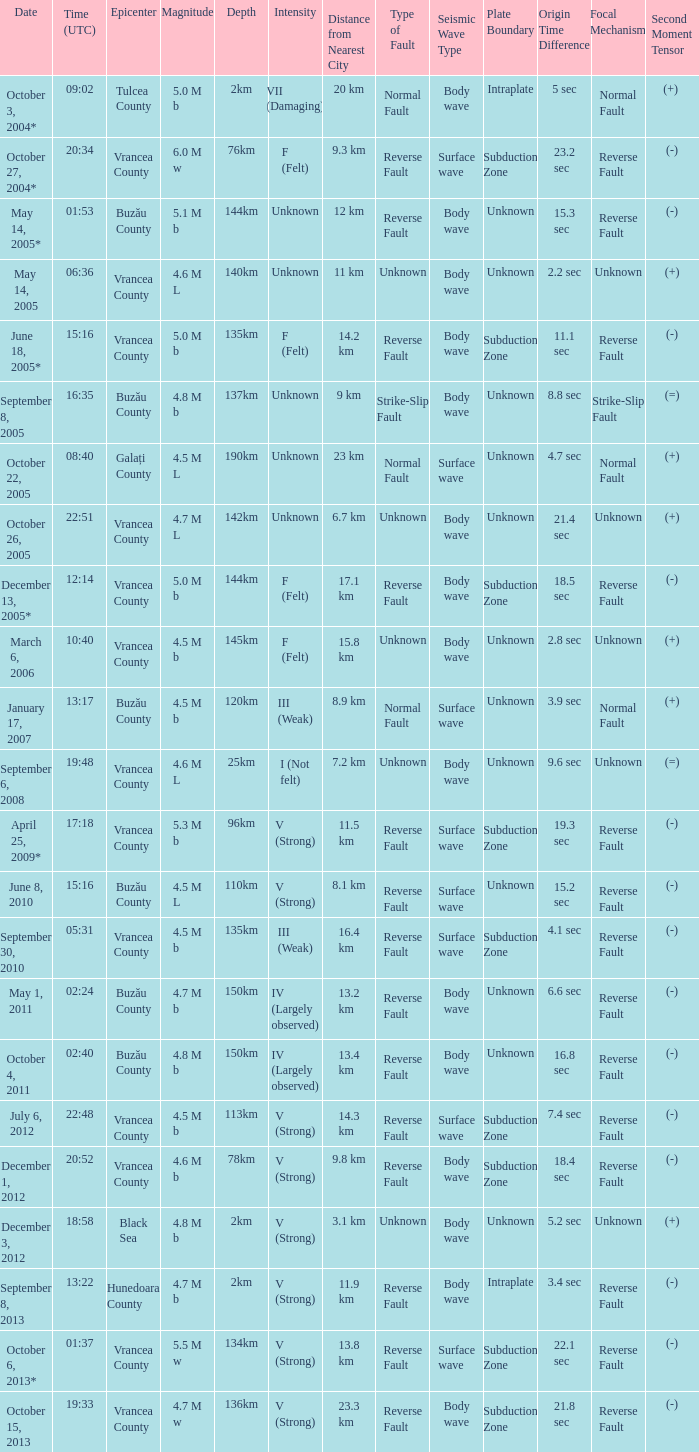Where was the epicenter of the quake on December 1, 2012? Vrancea County. 